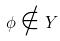Convert formula to latex. <formula><loc_0><loc_0><loc_500><loc_500>\phi \notin Y</formula> 